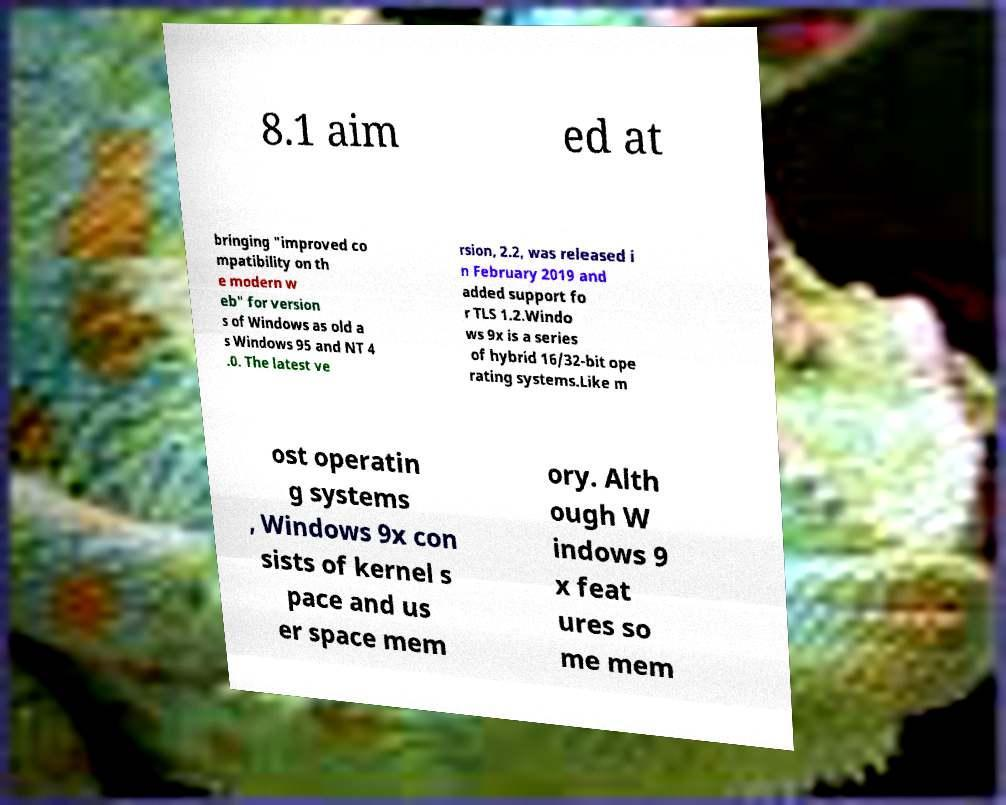For documentation purposes, I need the text within this image transcribed. Could you provide that? 8.1 aim ed at bringing "improved co mpatibility on th e modern w eb" for version s of Windows as old a s Windows 95 and NT 4 .0. The latest ve rsion, 2.2, was released i n February 2019 and added support fo r TLS 1.2.Windo ws 9x is a series of hybrid 16/32-bit ope rating systems.Like m ost operatin g systems , Windows 9x con sists of kernel s pace and us er space mem ory. Alth ough W indows 9 x feat ures so me mem 